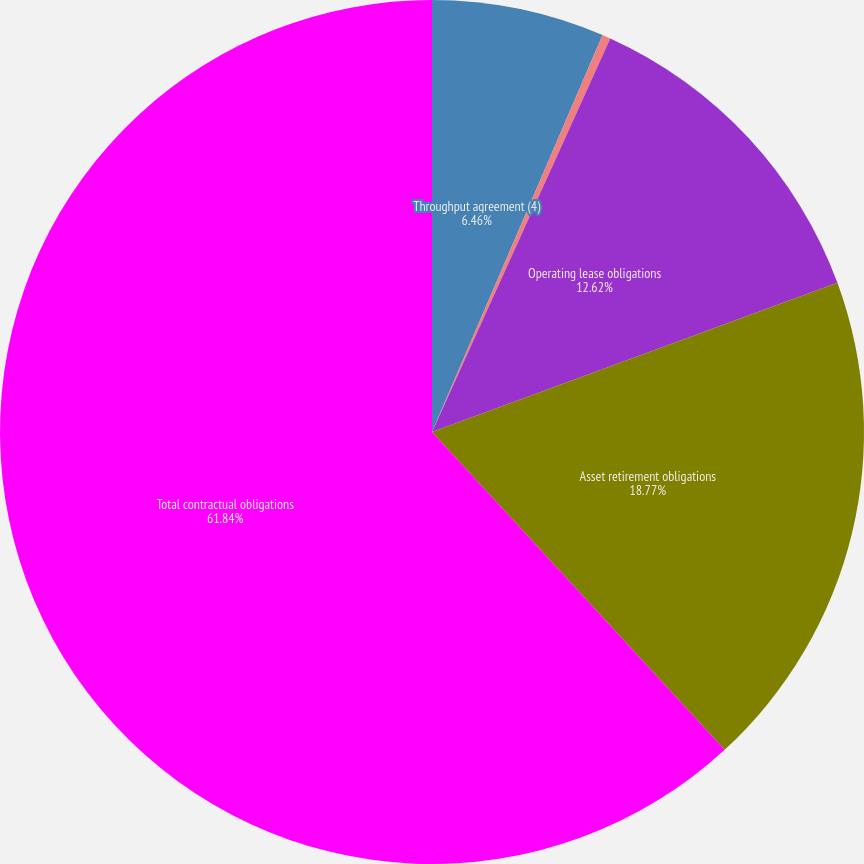Convert chart. <chart><loc_0><loc_0><loc_500><loc_500><pie_chart><fcel>Throughput agreement (4)<fcel>Transportation and gathering<fcel>Operating lease obligations<fcel>Asset retirement obligations<fcel>Total contractual obligations<nl><fcel>6.46%<fcel>0.31%<fcel>12.62%<fcel>18.77%<fcel>61.85%<nl></chart> 